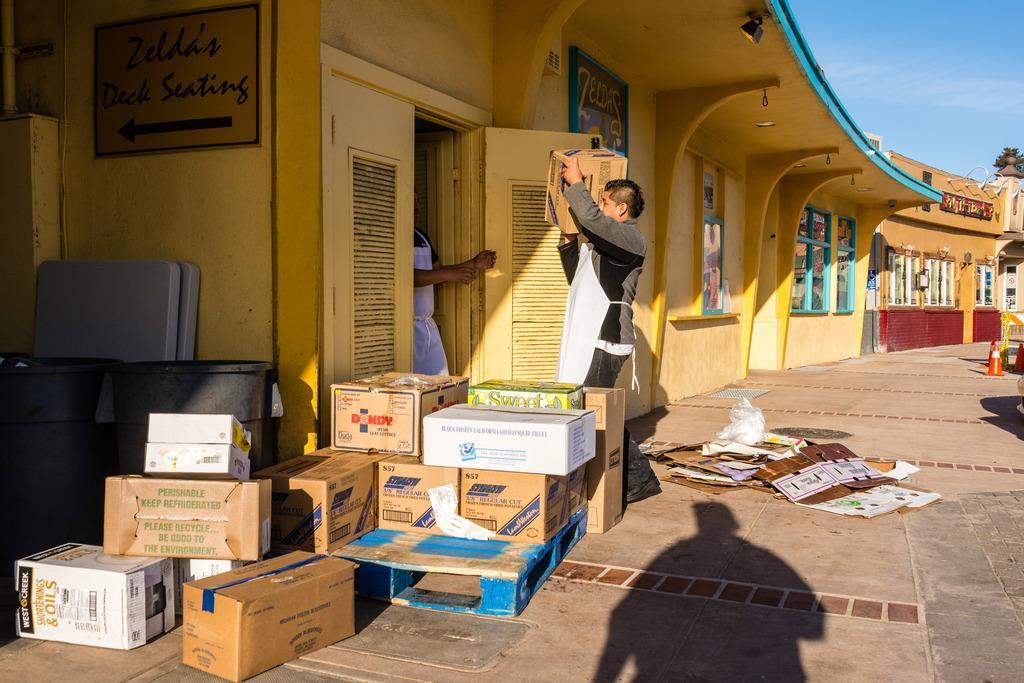Describe this image in one or two sentences. This picture is clicked outside the city. The man in grey jacket who is wearing a white apron is holding a carton box. In front of him, we see a man in white T-shirt is standing. Beside them, we see a yellow door. Beside that, there are many carton boxes. Beside that, we see grey color boards. Behind that, we see a yellow wall on which a board is placed. We see some text written on the board. There are buildings in the background. On the right side, we see a traffic stopper. In the right top of the picture, we see the sky. At the bottom of the picture, we see the shadow of the man standing. 